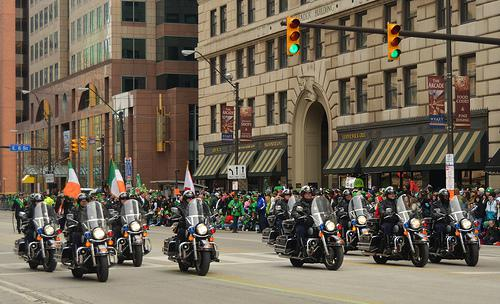Question: how many traffic lights are there?
Choices:
A. 1.
B. 3.
C. 4.
D. 2.
Answer with the letter. Answer: D Question: what are the people doing?
Choices:
A. Singing.
B. Walking.
C. Watching the parade.
D. Talking.
Answer with the letter. Answer: C Question: why are there so many motorcycles?
Choices:
A. A parade.
B. A funeral.
C. A show.
D. Coincidence.
Answer with the letter. Answer: A Question: what are the motorcycles riding on?
Choices:
A. Dirt.
B. Asphalt.
C. Cobblestone.
D. A road.
Answer with the letter. Answer: D Question: what color are the lights in the traffic lights?
Choices:
A. Green.
B. Red.
C. Yellow.
D. Orange.
Answer with the letter. Answer: A Question: what is the roadway made of?
Choices:
A. Asphalt.
B. Dirt.
C. Clay.
D. Concrete.
Answer with the letter. Answer: A Question: where is the crowd of people?
Choices:
A. Behind the house.
B. Side of the road.
C. Beside the fountain.
D. On the fence.
Answer with the letter. Answer: B 